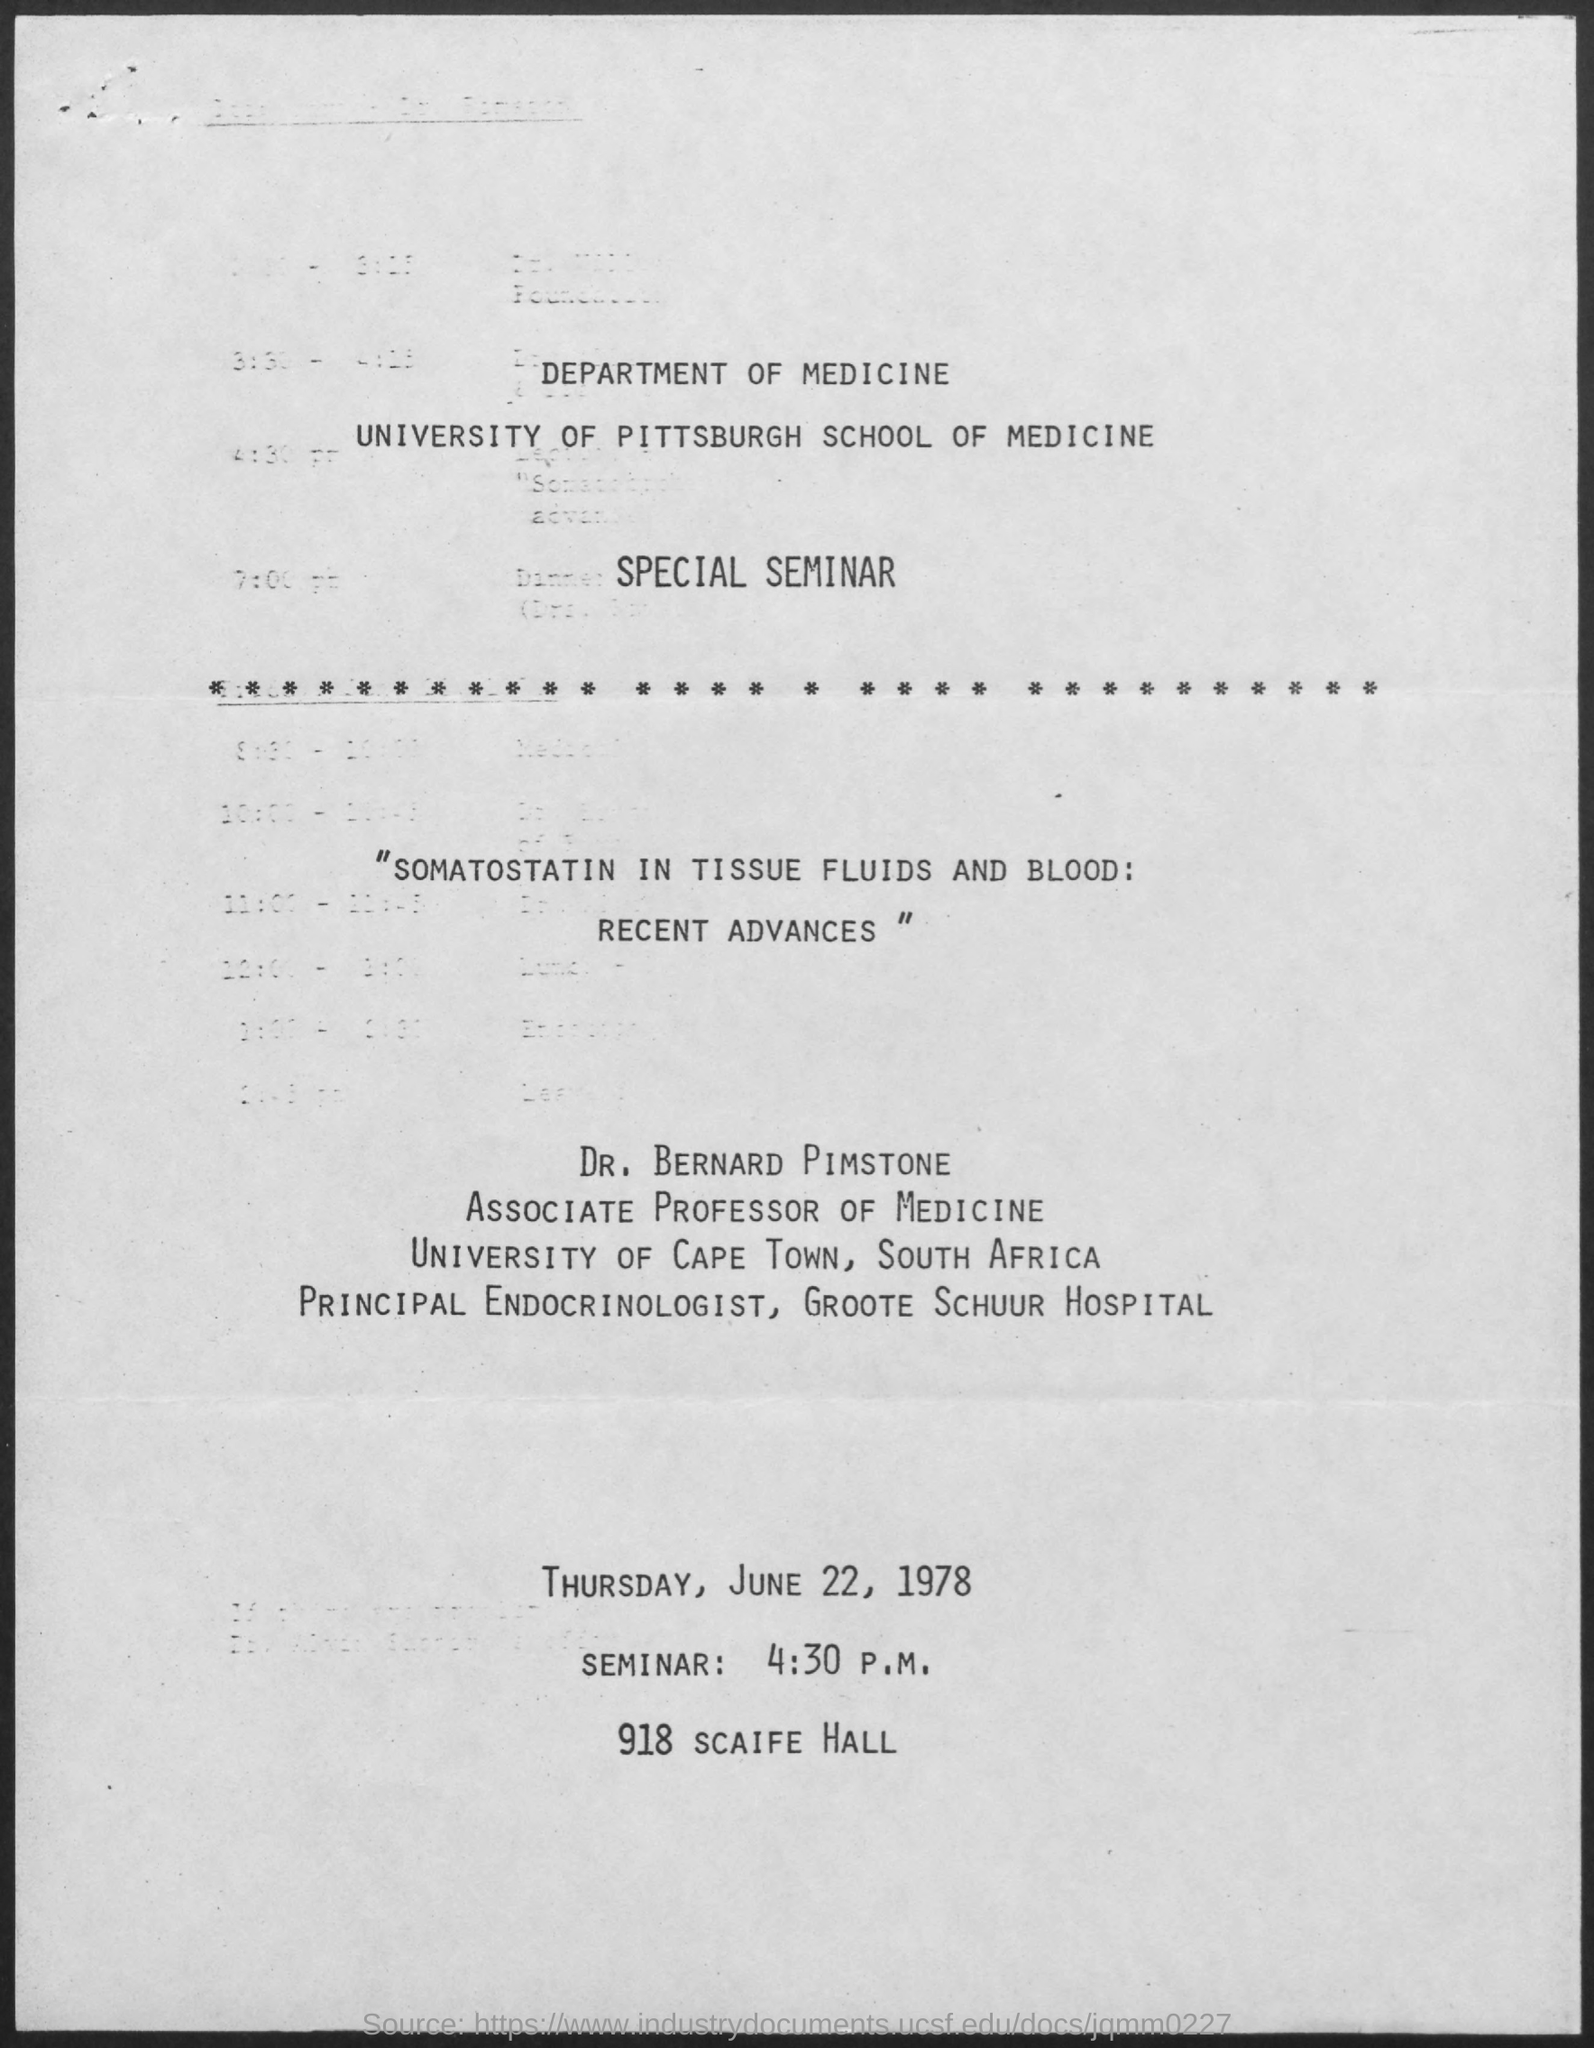When is the Seminar?
Offer a very short reply. Thursday, June 22, 1978. What is the time of the Seminar?
Your answer should be very brief. 4:30 P.M. Where is the seminar held?
Give a very brief answer. 918 Scaife Hall. Who presents the seminar?
Your answer should be very brief. Dr. Bernard Pimstone. 